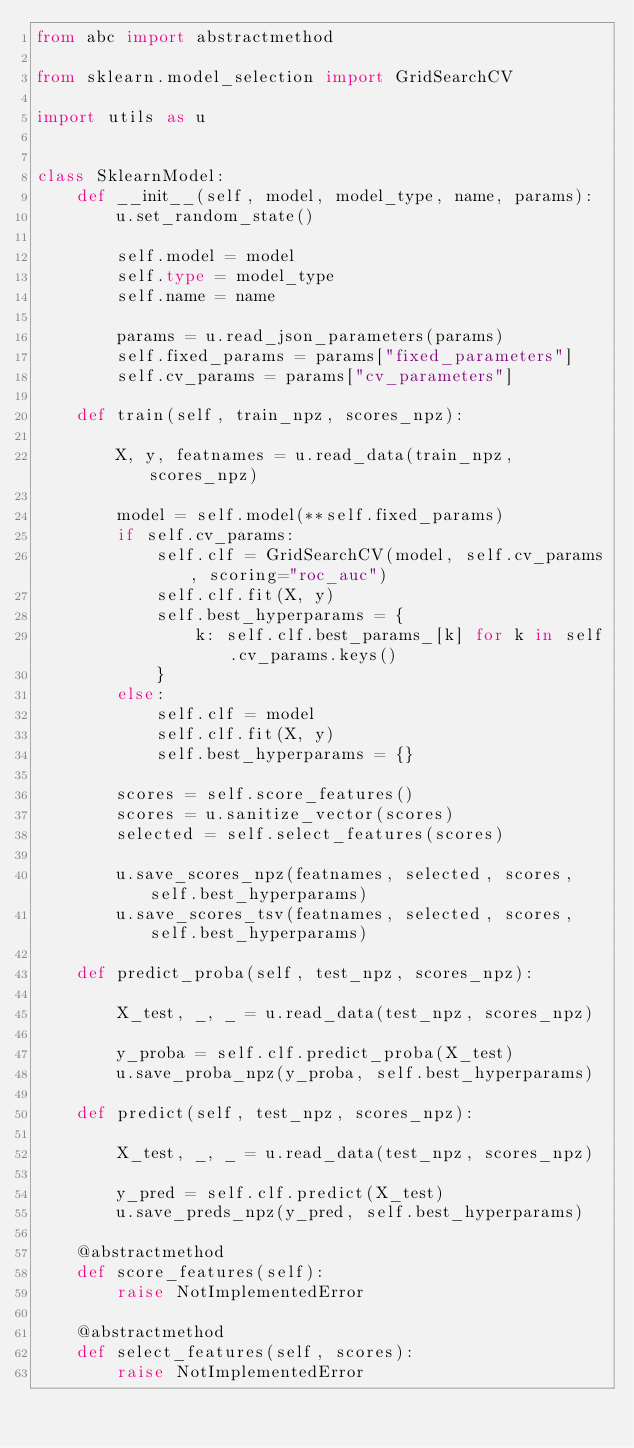Convert code to text. <code><loc_0><loc_0><loc_500><loc_500><_Python_>from abc import abstractmethod

from sklearn.model_selection import GridSearchCV

import utils as u


class SklearnModel:
    def __init__(self, model, model_type, name, params):
        u.set_random_state()

        self.model = model
        self.type = model_type
        self.name = name

        params = u.read_json_parameters(params)
        self.fixed_params = params["fixed_parameters"]
        self.cv_params = params["cv_parameters"]

    def train(self, train_npz, scores_npz):

        X, y, featnames = u.read_data(train_npz, scores_npz)

        model = self.model(**self.fixed_params)
        if self.cv_params:
            self.clf = GridSearchCV(model, self.cv_params, scoring="roc_auc")
            self.clf.fit(X, y)
            self.best_hyperparams = {
                k: self.clf.best_params_[k] for k in self.cv_params.keys()
            }
        else:
            self.clf = model
            self.clf.fit(X, y)
            self.best_hyperparams = {}

        scores = self.score_features()
        scores = u.sanitize_vector(scores)
        selected = self.select_features(scores)

        u.save_scores_npz(featnames, selected, scores, self.best_hyperparams)
        u.save_scores_tsv(featnames, selected, scores, self.best_hyperparams)

    def predict_proba(self, test_npz, scores_npz):

        X_test, _, _ = u.read_data(test_npz, scores_npz)

        y_proba = self.clf.predict_proba(X_test)
        u.save_proba_npz(y_proba, self.best_hyperparams)

    def predict(self, test_npz, scores_npz):

        X_test, _, _ = u.read_data(test_npz, scores_npz)

        y_pred = self.clf.predict(X_test)
        u.save_preds_npz(y_pred, self.best_hyperparams)

    @abstractmethod
    def score_features(self):
        raise NotImplementedError

    @abstractmethod
    def select_features(self, scores):
        raise NotImplementedError
</code> 